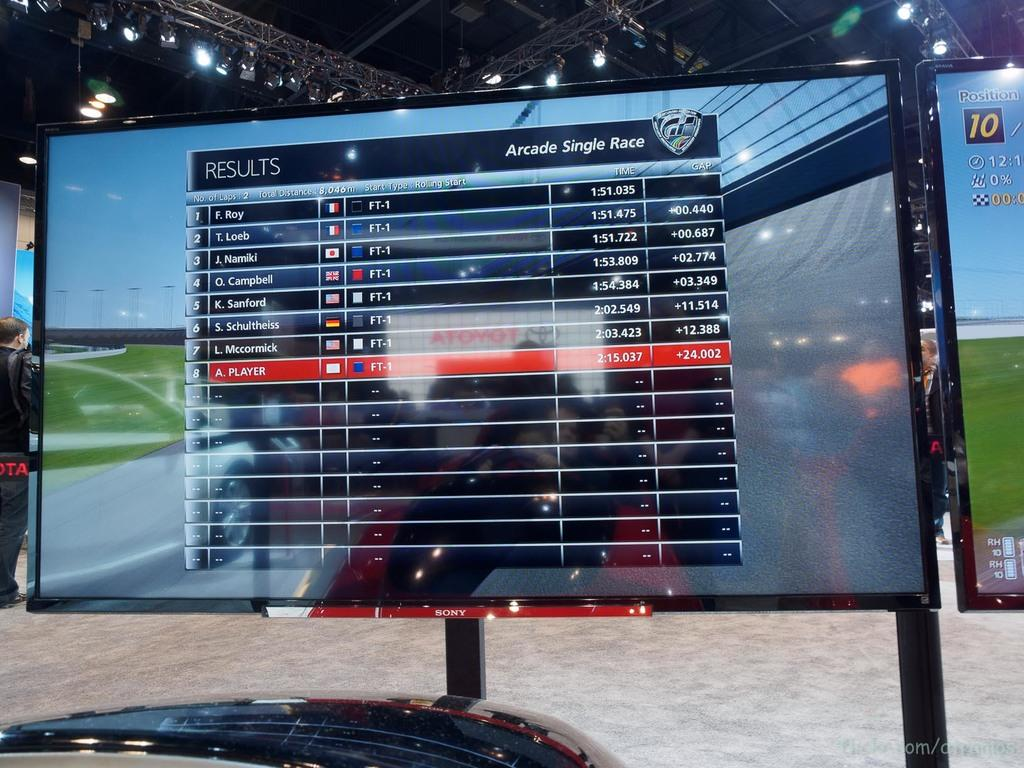Provide a one-sentence caption for the provided image. A monitor displays a grid with"results" in the left corner. 